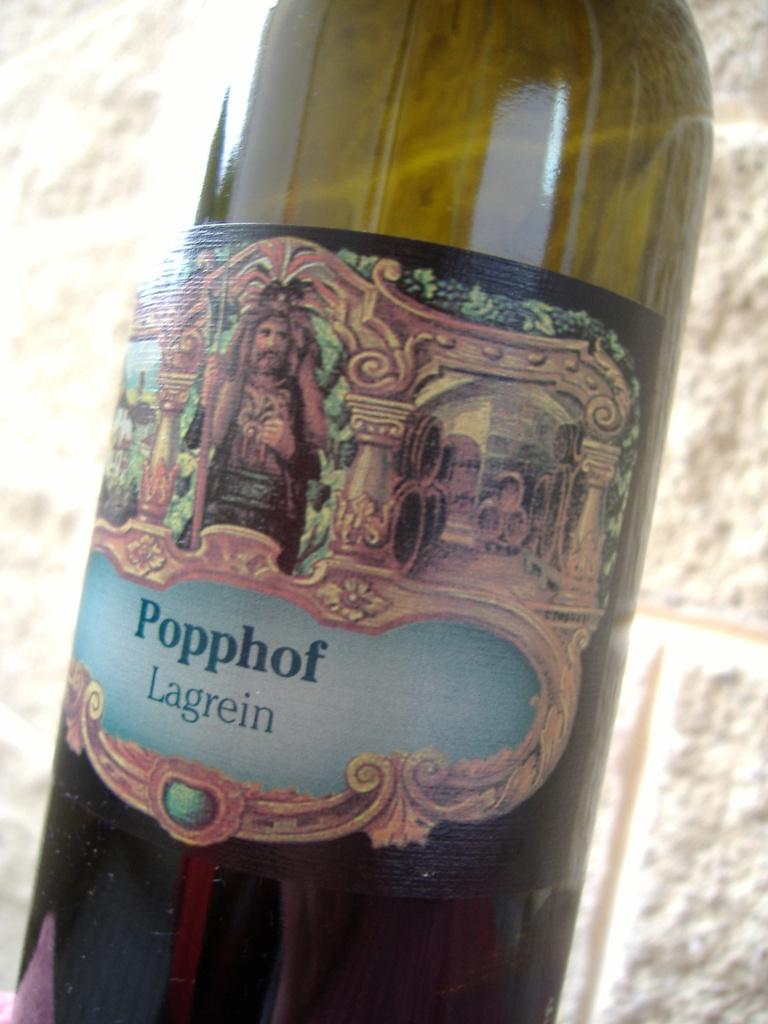Popular video website?
Offer a terse response. Not a question. 